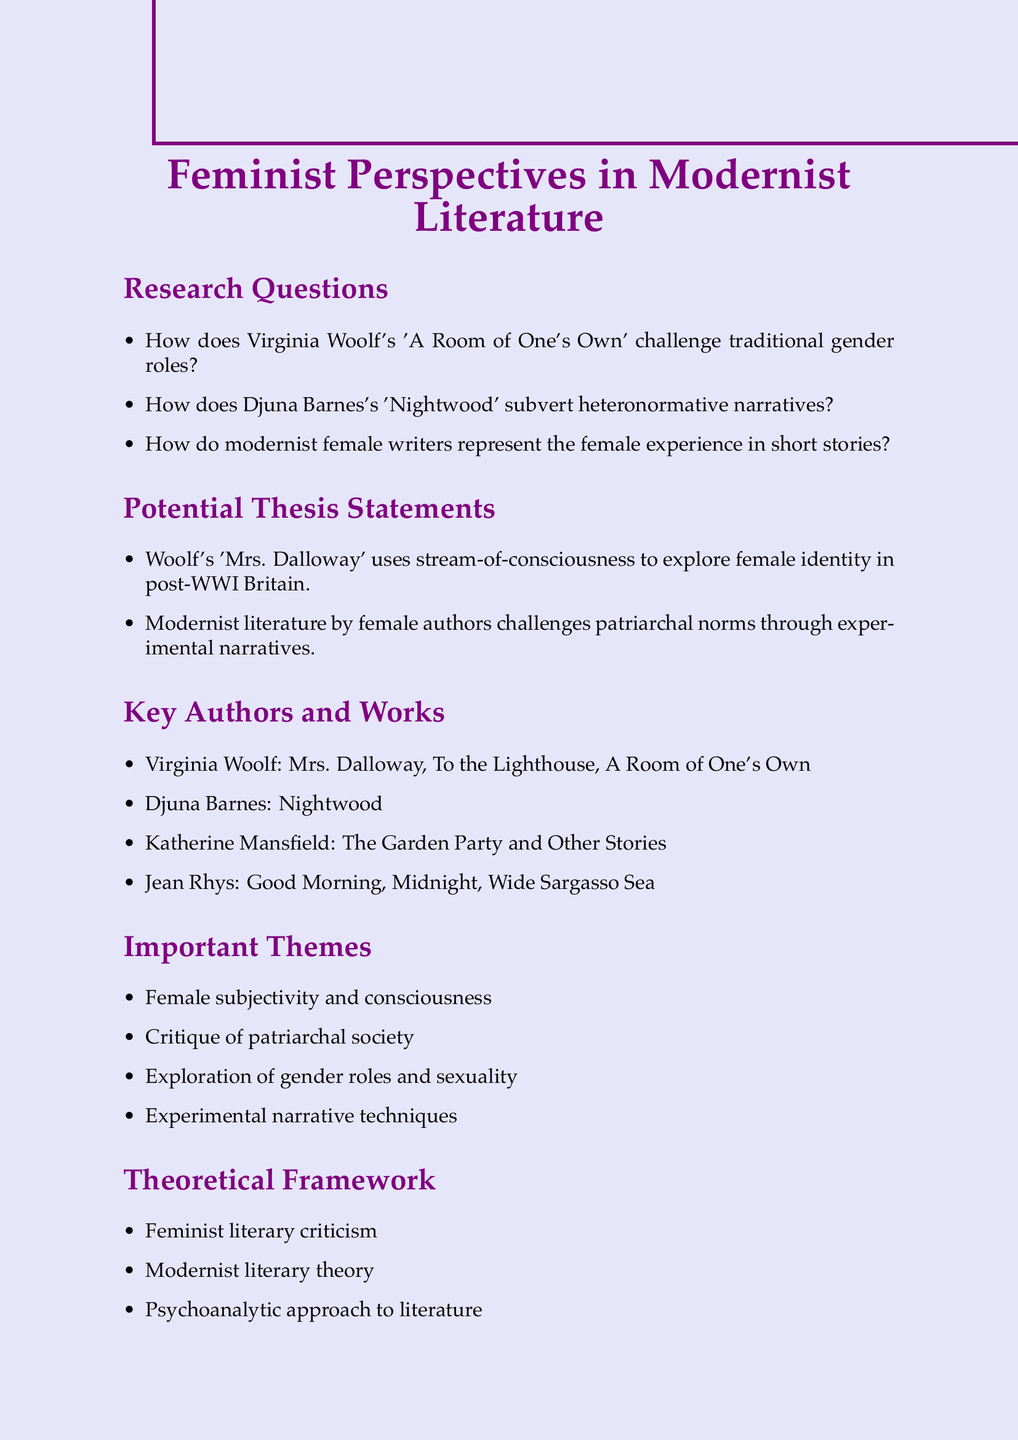What is the first research question listed? The first research question is about Virginia Woolf's work 'A Room of One's Own' and traditional gender roles.
Answer: How does Virginia Woolf's 'A Room of One's Own' challenge traditional gender roles in early 20th-century literature? Who is the author of 'Nightwood'? 'Nightwood' is a work written by Djuna Barnes, as mentioned in the key authors and works section.
Answer: Djuna Barnes What are the important themes noted in the document? The document identifies several themes, including female subjectivity and consciousness, which are central to the analysis of feminist literature.
Answer: Female subjectivity and consciousness Name one potential thesis statement. One potential thesis statement discusses the narrative technique in Woolf's 'Mrs. Dalloway.'
Answer: Virginia Woolf's 'Mrs. Dalloway' employs stream-of-consciousness narrative technique to explore the complexities of female identity in post-World War I Britain How many key authors are mentioned in the document? The document lists four key authors whose works contribute to feminist perspectives in modernist literature.
Answer: Four What type of literary criticism is included in the theoretical framework? The theoretical framework section discusses feminist literary criticism as one of the approaches to analyze the texts.
Answer: Feminist literary criticism Which year was 'Sexual/Textual Politics: Feminist Literary Theory' published? The publication year of 'Sexual/Textual Politics: Feminist Literary Theory' is provided alongside the author's name in the scholarly resources section.
Answer: 2002 